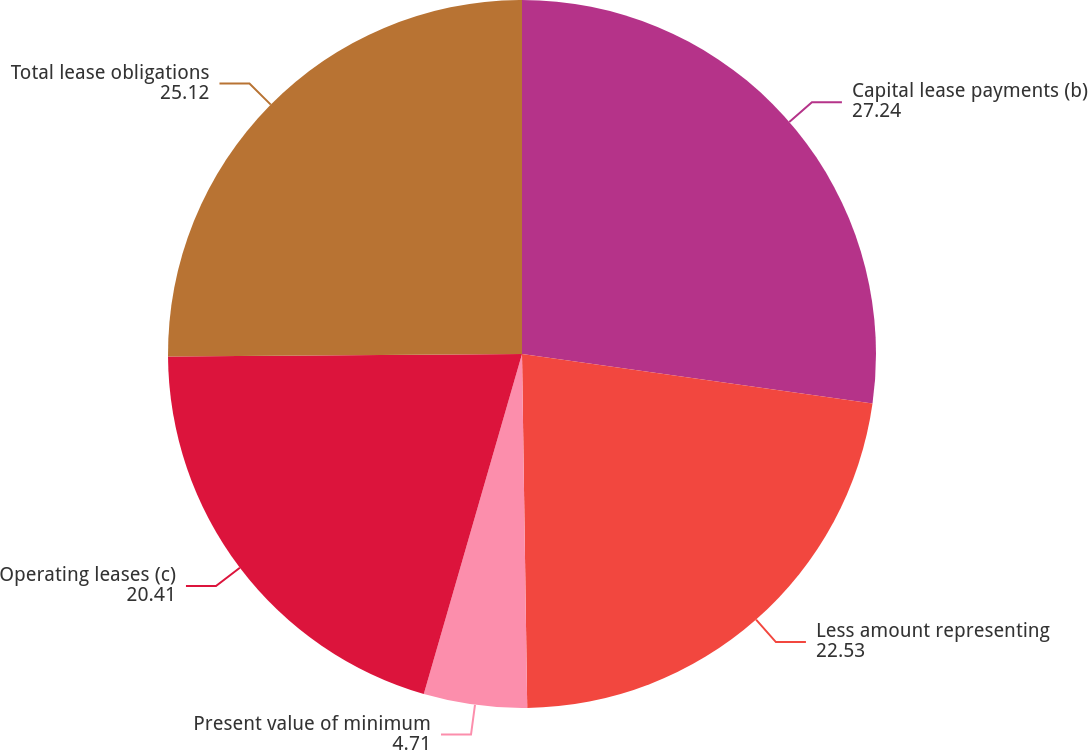<chart> <loc_0><loc_0><loc_500><loc_500><pie_chart><fcel>Capital lease payments (b)<fcel>Less amount representing<fcel>Present value of minimum<fcel>Operating leases (c)<fcel>Total lease obligations<nl><fcel>27.24%<fcel>22.53%<fcel>4.71%<fcel>20.41%<fcel>25.12%<nl></chart> 